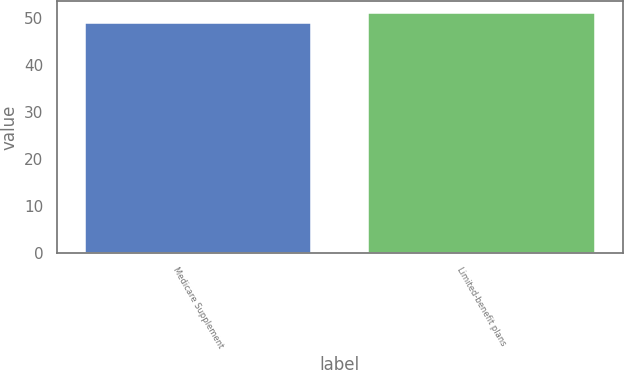<chart> <loc_0><loc_0><loc_500><loc_500><bar_chart><fcel>Medicare Supplement<fcel>Limited-benefit plans<nl><fcel>49<fcel>51<nl></chart> 